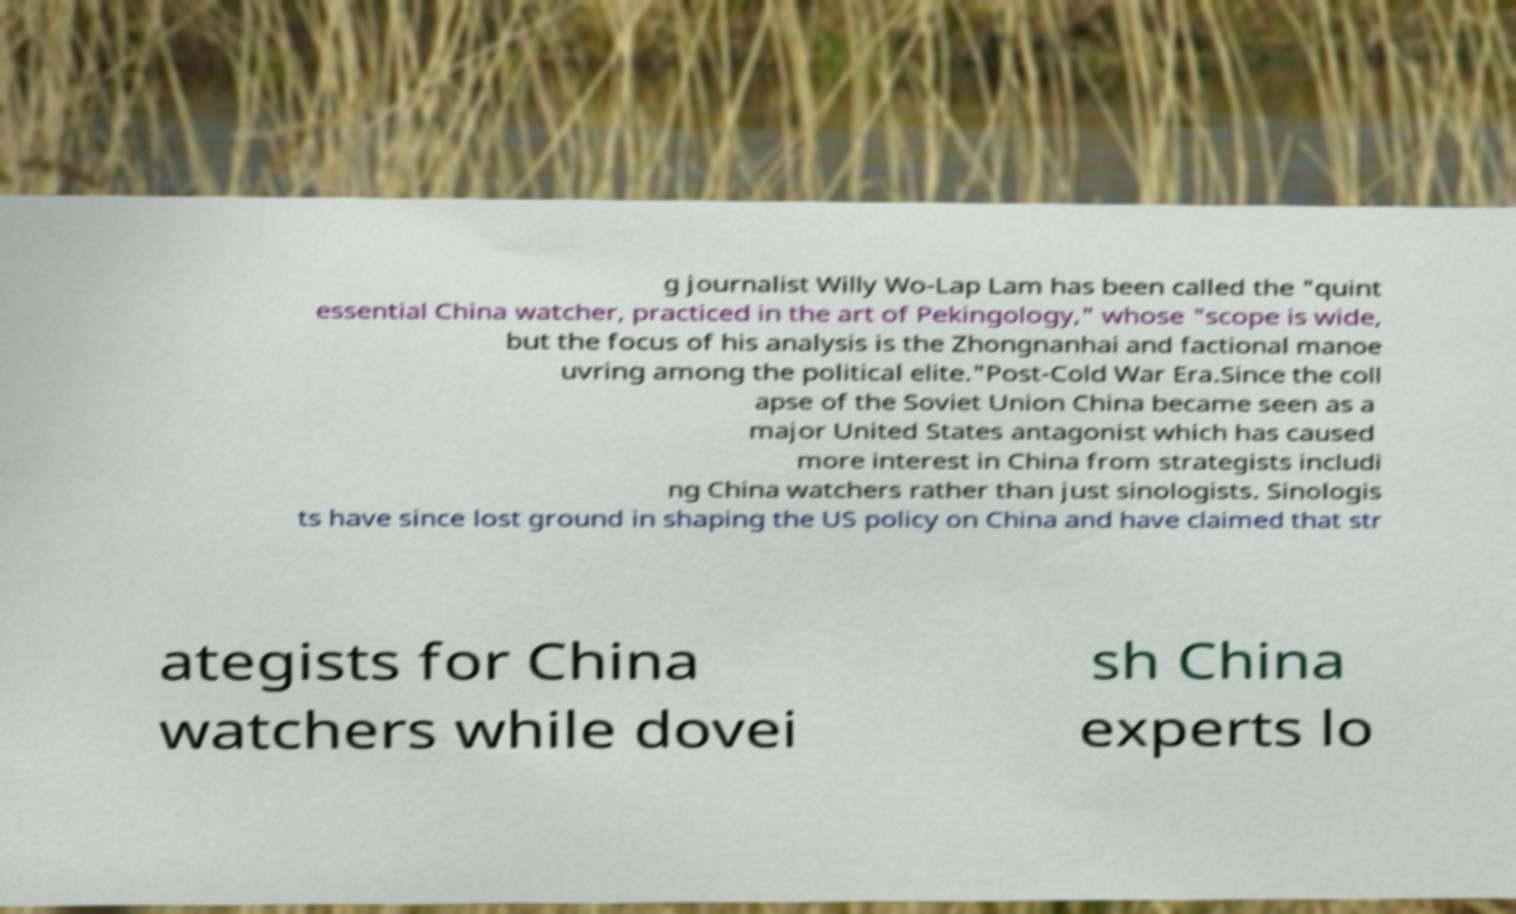Could you extract and type out the text from this image? g journalist Willy Wo-Lap Lam has been called the "quint essential China watcher, practiced in the art of Pekingology," whose "scope is wide, but the focus of his analysis is the Zhongnanhai and factional manoe uvring among the political elite."Post-Cold War Era.Since the coll apse of the Soviet Union China became seen as a major United States antagonist which has caused more interest in China from strategists includi ng China watchers rather than just sinologists. Sinologis ts have since lost ground in shaping the US policy on China and have claimed that str ategists for China watchers while dovei sh China experts lo 